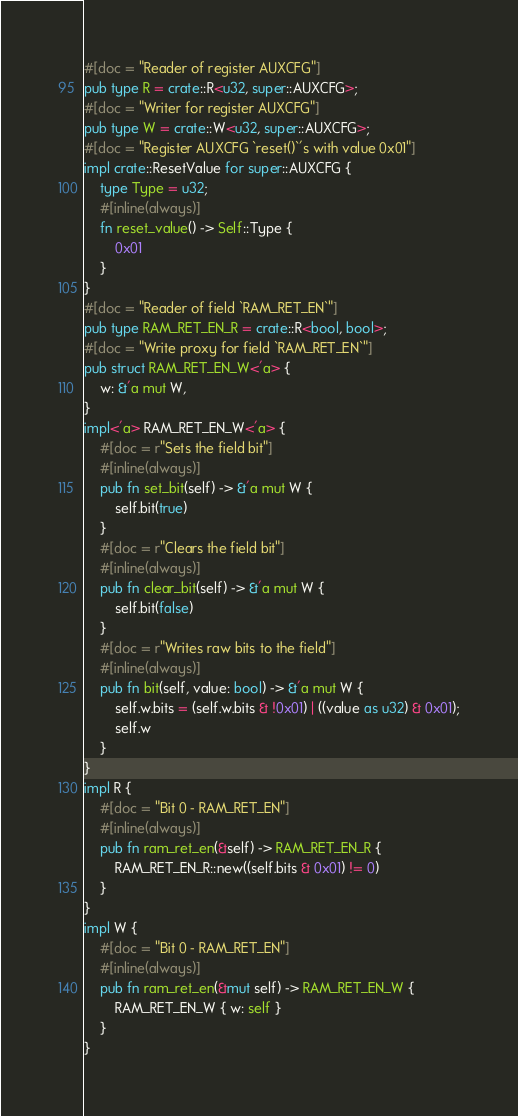Convert code to text. <code><loc_0><loc_0><loc_500><loc_500><_Rust_>#[doc = "Reader of register AUXCFG"]
pub type R = crate::R<u32, super::AUXCFG>;
#[doc = "Writer for register AUXCFG"]
pub type W = crate::W<u32, super::AUXCFG>;
#[doc = "Register AUXCFG `reset()`'s with value 0x01"]
impl crate::ResetValue for super::AUXCFG {
    type Type = u32;
    #[inline(always)]
    fn reset_value() -> Self::Type {
        0x01
    }
}
#[doc = "Reader of field `RAM_RET_EN`"]
pub type RAM_RET_EN_R = crate::R<bool, bool>;
#[doc = "Write proxy for field `RAM_RET_EN`"]
pub struct RAM_RET_EN_W<'a> {
    w: &'a mut W,
}
impl<'a> RAM_RET_EN_W<'a> {
    #[doc = r"Sets the field bit"]
    #[inline(always)]
    pub fn set_bit(self) -> &'a mut W {
        self.bit(true)
    }
    #[doc = r"Clears the field bit"]
    #[inline(always)]
    pub fn clear_bit(self) -> &'a mut W {
        self.bit(false)
    }
    #[doc = r"Writes raw bits to the field"]
    #[inline(always)]
    pub fn bit(self, value: bool) -> &'a mut W {
        self.w.bits = (self.w.bits & !0x01) | ((value as u32) & 0x01);
        self.w
    }
}
impl R {
    #[doc = "Bit 0 - RAM_RET_EN"]
    #[inline(always)]
    pub fn ram_ret_en(&self) -> RAM_RET_EN_R {
        RAM_RET_EN_R::new((self.bits & 0x01) != 0)
    }
}
impl W {
    #[doc = "Bit 0 - RAM_RET_EN"]
    #[inline(always)]
    pub fn ram_ret_en(&mut self) -> RAM_RET_EN_W {
        RAM_RET_EN_W { w: self }
    }
}
</code> 